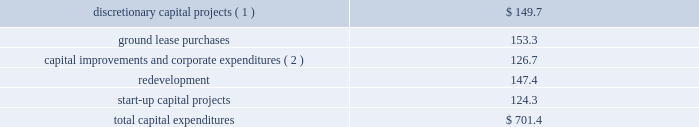As of december 31 , 2016 , we had total outstanding indebtedness of $ 18.7 billion , with a current portion of $ 238.8 million .
During the year ended december 31 , 2016 , we generated sufficient cash flow from operations to fund our capital expenditures and debt service obligations , as well as our required distributions .
We believe the cash generated by operating activities during the year ending december 31 , 2017 will be sufficient to fund our required distributions , capital expenditures , debt service obligations ( interest and principal repayments ) and signed acquisitions .
As of december 31 , 2016 , we had $ 423.0 million of cash and cash equivalents held by our foreign subsidiaries , of which $ 183.9 million was held by our joint ventures .
While certain subsidiaries may pay us interest or principal on intercompany debt , it has not been our practice to repatriate earnings from our foreign subsidiaries primarily due to our ongoing expansion efforts and related capital needs .
However , in the event that we do repatriate any funds , we may be required to accrue and pay taxes .
Cash flows from operating activities for the year ended december 31 , 2016 , cash provided by operating activities increased $ 520.6 million as compared to the year ended december 31 , 2015 .
The primary factors that impacted cash provided by operating activities as compared to the year ended december 31 , 2015 , include : 2022 an increase in our operating profit of $ 490.8 million ; 2022 an increase of approximately $ 67.1 million in cash paid for interest ; and 2022 a decrease of approximately $ 60.8 million in cash paid for taxes .
For the year ended december 31 , 2015 , cash provided by operating activities increased $ 48.5 million as compared to the year ended december 31 , 2014 .
The primary factors that impacted cash provided by operating activities as compared to the year ended december 31 , 2014 , include : 2022 an increase in our operating profit of $ 433.3 million ; 2022 an increase of approximately $ 87.8 million in cash paid for taxes , driven primarily by the mipt one-time cash tax charge of $ 93.0 million ; 2022 a decrease in capital contributions , tenant settlements and other prepayments of approximately $ 99.0 million ; 2022 an increase of approximately $ 29.9 million in cash paid for interest ; 2022 a decrease of approximately $ 34.9 million in termination and decommissioning fees ; 2022 a decrease of approximately $ 49.0 million in tenant receipts due to timing ; and 2022 a decrease due to the non-recurrence of a 2014 value added tax refund of approximately $ 60.3 million .
Cash flows from investing activities our significant investing activities during the year ended december 31 , 2016 are highlighted below : 2022 we spent approximately $ 1.1 billion for the viom acquisition .
2022 we spent $ 701.4 million for capital expenditures , as follows ( in millions ) : .
_______________ ( 1 ) includes the construction of 1869 communications sites globally .
( 2 ) includes $ 18.9 million of capital lease payments included in repayments of notes payable , credit facilities , term loan , senior notes and capital leases in the cash flow from financing activities in our consolidated statement of cash flows .
Our significant investing transactions in 2015 included the following : 2022 we spent $ 5.059 billion for the verizon transaction .
2022 we spent $ 796.9 million for the acquisition of 5483 communications sites from tim in brazil .
2022 we spent $ 1.1 billion for the acquisition of 4716 communications sites from certain of airtel 2019s subsidiaries in nigeria. .
As of december 31 , 2016 what was the percent of the total capital expenditures spent on ground lease purchases? 
Computations: (153.3 / 701.4)
Answer: 0.21856. 